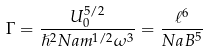Convert formula to latex. <formula><loc_0><loc_0><loc_500><loc_500>\Gamma = \frac { U _ { 0 } ^ { 5 / 2 } } { \hslash ^ { 2 } N a m ^ { 1 / 2 } \omega ^ { 3 } } = \frac { \ell ^ { 6 } } { N a B ^ { 5 } }</formula> 